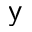Convert formula to latex. <formula><loc_0><loc_0><loc_500><loc_500>y</formula> 